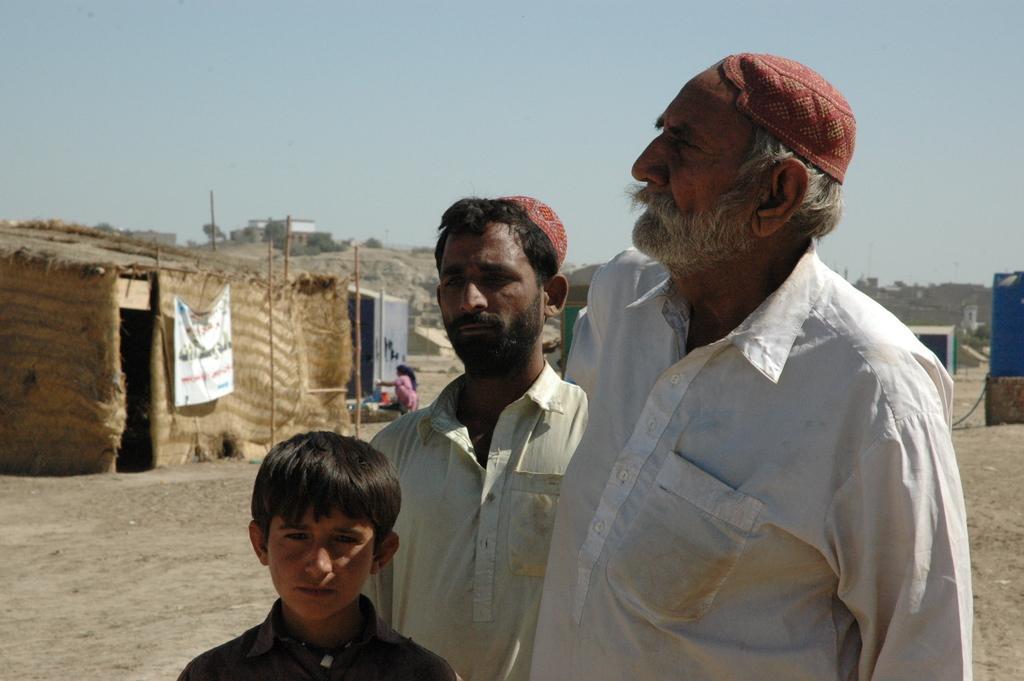Could you give a brief overview of what you see in this image? Here a man is standing he wore a white color shirt and a dark red color cap. In the left side it is a hut, at the top it's a sunny sky. 